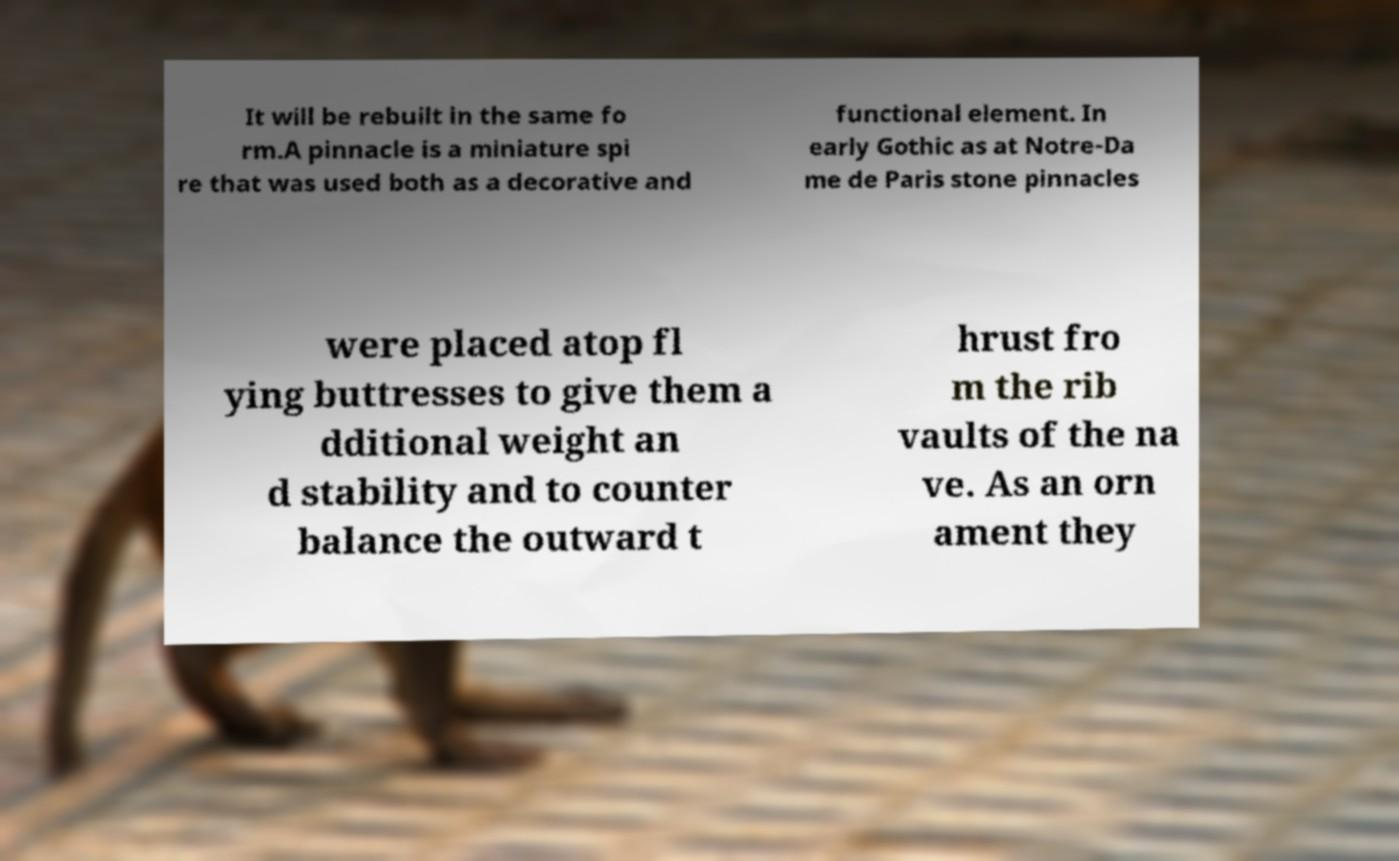Please identify and transcribe the text found in this image. It will be rebuilt in the same fo rm.A pinnacle is a miniature spi re that was used both as a decorative and functional element. In early Gothic as at Notre-Da me de Paris stone pinnacles were placed atop fl ying buttresses to give them a dditional weight an d stability and to counter balance the outward t hrust fro m the rib vaults of the na ve. As an orn ament they 